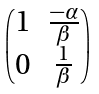Convert formula to latex. <formula><loc_0><loc_0><loc_500><loc_500>\begin{pmatrix} 1 & \frac { - \alpha } { \beta } \\ 0 & \frac { 1 } { \beta } \end{pmatrix}</formula> 